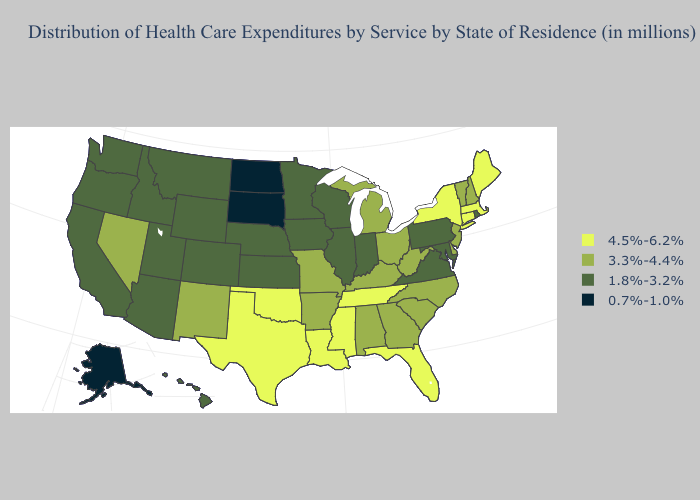Name the states that have a value in the range 1.8%-3.2%?
Answer briefly. Arizona, California, Colorado, Hawaii, Idaho, Illinois, Indiana, Iowa, Kansas, Maryland, Minnesota, Montana, Nebraska, Oregon, Pennsylvania, Rhode Island, Utah, Virginia, Washington, Wisconsin, Wyoming. What is the highest value in the USA?
Write a very short answer. 4.5%-6.2%. What is the value of Tennessee?
Answer briefly. 4.5%-6.2%. Does Alaska have the lowest value in the USA?
Write a very short answer. Yes. What is the value of Georgia?
Quick response, please. 3.3%-4.4%. Does Pennsylvania have the lowest value in the USA?
Keep it brief. No. What is the value of Tennessee?
Be succinct. 4.5%-6.2%. Does Delaware have the highest value in the USA?
Concise answer only. No. What is the value of Indiana?
Be succinct. 1.8%-3.2%. Name the states that have a value in the range 4.5%-6.2%?
Quick response, please. Connecticut, Florida, Louisiana, Maine, Massachusetts, Mississippi, New York, Oklahoma, Tennessee, Texas. Does Oklahoma have the highest value in the USA?
Quick response, please. Yes. Is the legend a continuous bar?
Be succinct. No. Name the states that have a value in the range 4.5%-6.2%?
Give a very brief answer. Connecticut, Florida, Louisiana, Maine, Massachusetts, Mississippi, New York, Oklahoma, Tennessee, Texas. Name the states that have a value in the range 1.8%-3.2%?
Quick response, please. Arizona, California, Colorado, Hawaii, Idaho, Illinois, Indiana, Iowa, Kansas, Maryland, Minnesota, Montana, Nebraska, Oregon, Pennsylvania, Rhode Island, Utah, Virginia, Washington, Wisconsin, Wyoming. What is the lowest value in the USA?
Concise answer only. 0.7%-1.0%. 